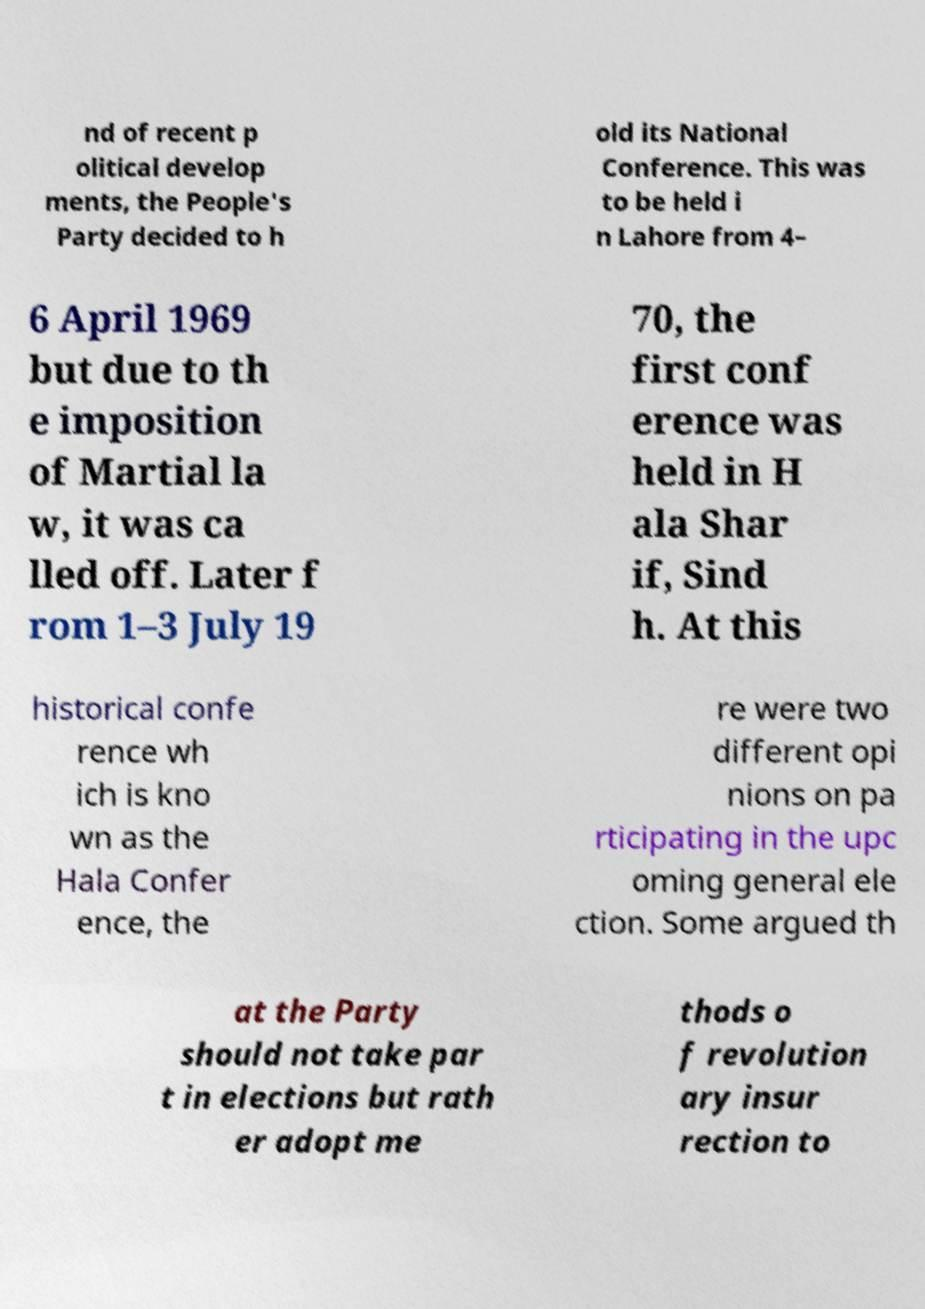For documentation purposes, I need the text within this image transcribed. Could you provide that? nd of recent p olitical develop ments, the People's Party decided to h old its National Conference. This was to be held i n Lahore from 4– 6 April 1969 but due to th e imposition of Martial la w, it was ca lled off. Later f rom 1–3 July 19 70, the first conf erence was held in H ala Shar if, Sind h. At this historical confe rence wh ich is kno wn as the Hala Confer ence, the re were two different opi nions on pa rticipating in the upc oming general ele ction. Some argued th at the Party should not take par t in elections but rath er adopt me thods o f revolution ary insur rection to 